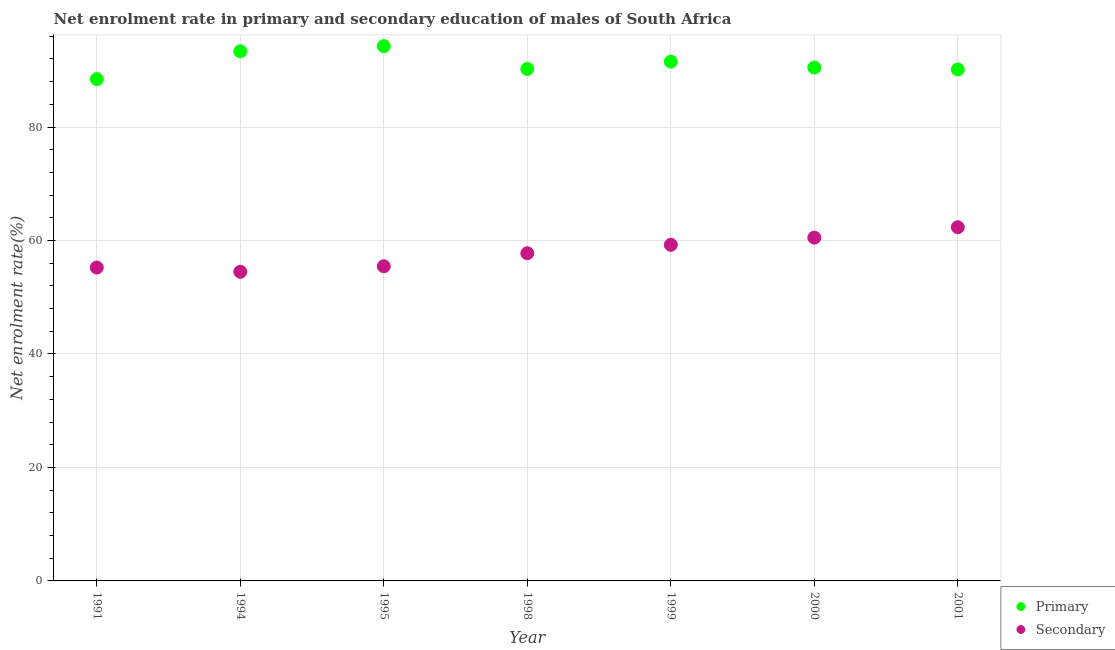How many different coloured dotlines are there?
Your answer should be very brief. 2. Is the number of dotlines equal to the number of legend labels?
Your answer should be very brief. Yes. What is the enrollment rate in primary education in 1994?
Your response must be concise. 93.36. Across all years, what is the maximum enrollment rate in secondary education?
Offer a terse response. 62.34. Across all years, what is the minimum enrollment rate in primary education?
Your answer should be compact. 88.45. In which year was the enrollment rate in secondary education maximum?
Ensure brevity in your answer.  2001. In which year was the enrollment rate in secondary education minimum?
Your answer should be compact. 1994. What is the total enrollment rate in secondary education in the graph?
Provide a short and direct response. 405.04. What is the difference between the enrollment rate in primary education in 1998 and that in 2001?
Provide a short and direct response. 0.09. What is the difference between the enrollment rate in primary education in 1999 and the enrollment rate in secondary education in 2000?
Provide a succinct answer. 31.02. What is the average enrollment rate in primary education per year?
Ensure brevity in your answer.  91.21. In the year 2000, what is the difference between the enrollment rate in secondary education and enrollment rate in primary education?
Your answer should be compact. -29.98. What is the ratio of the enrollment rate in primary education in 1995 to that in 2000?
Your answer should be very brief. 1.04. Is the enrollment rate in primary education in 1995 less than that in 1998?
Offer a terse response. No. What is the difference between the highest and the second highest enrollment rate in primary education?
Ensure brevity in your answer.  0.9. What is the difference between the highest and the lowest enrollment rate in primary education?
Make the answer very short. 5.81. Is the enrollment rate in secondary education strictly less than the enrollment rate in primary education over the years?
Make the answer very short. Yes. How many dotlines are there?
Offer a terse response. 2. How many years are there in the graph?
Offer a very short reply. 7. What is the difference between two consecutive major ticks on the Y-axis?
Your response must be concise. 20. How many legend labels are there?
Offer a very short reply. 2. What is the title of the graph?
Make the answer very short. Net enrolment rate in primary and secondary education of males of South Africa. Does "Non-residents" appear as one of the legend labels in the graph?
Ensure brevity in your answer.  No. What is the label or title of the X-axis?
Your answer should be compact. Year. What is the label or title of the Y-axis?
Offer a very short reply. Net enrolment rate(%). What is the Net enrolment rate(%) of Primary in 1991?
Make the answer very short. 88.45. What is the Net enrolment rate(%) of Secondary in 1991?
Make the answer very short. 55.24. What is the Net enrolment rate(%) in Primary in 1994?
Ensure brevity in your answer.  93.36. What is the Net enrolment rate(%) of Secondary in 1994?
Keep it short and to the point. 54.49. What is the Net enrolment rate(%) in Primary in 1995?
Your answer should be compact. 94.26. What is the Net enrolment rate(%) in Secondary in 1995?
Provide a short and direct response. 55.46. What is the Net enrolment rate(%) in Primary in 1998?
Give a very brief answer. 90.24. What is the Net enrolment rate(%) in Secondary in 1998?
Offer a terse response. 57.76. What is the Net enrolment rate(%) in Primary in 1999?
Offer a terse response. 91.53. What is the Net enrolment rate(%) in Secondary in 1999?
Provide a succinct answer. 59.24. What is the Net enrolment rate(%) of Primary in 2000?
Make the answer very short. 90.49. What is the Net enrolment rate(%) in Secondary in 2000?
Keep it short and to the point. 60.51. What is the Net enrolment rate(%) in Primary in 2001?
Provide a short and direct response. 90.15. What is the Net enrolment rate(%) in Secondary in 2001?
Offer a terse response. 62.34. Across all years, what is the maximum Net enrolment rate(%) in Primary?
Provide a succinct answer. 94.26. Across all years, what is the maximum Net enrolment rate(%) of Secondary?
Provide a succinct answer. 62.34. Across all years, what is the minimum Net enrolment rate(%) in Primary?
Your answer should be compact. 88.45. Across all years, what is the minimum Net enrolment rate(%) of Secondary?
Provide a succinct answer. 54.49. What is the total Net enrolment rate(%) in Primary in the graph?
Your answer should be compact. 638.47. What is the total Net enrolment rate(%) in Secondary in the graph?
Your answer should be very brief. 405.04. What is the difference between the Net enrolment rate(%) of Primary in 1991 and that in 1994?
Offer a very short reply. -4.91. What is the difference between the Net enrolment rate(%) in Secondary in 1991 and that in 1994?
Offer a very short reply. 0.75. What is the difference between the Net enrolment rate(%) of Primary in 1991 and that in 1995?
Your answer should be very brief. -5.81. What is the difference between the Net enrolment rate(%) of Secondary in 1991 and that in 1995?
Offer a terse response. -0.22. What is the difference between the Net enrolment rate(%) in Primary in 1991 and that in 1998?
Your response must be concise. -1.79. What is the difference between the Net enrolment rate(%) in Secondary in 1991 and that in 1998?
Your answer should be compact. -2.51. What is the difference between the Net enrolment rate(%) in Primary in 1991 and that in 1999?
Keep it short and to the point. -3.08. What is the difference between the Net enrolment rate(%) of Secondary in 1991 and that in 1999?
Keep it short and to the point. -4. What is the difference between the Net enrolment rate(%) of Primary in 1991 and that in 2000?
Ensure brevity in your answer.  -2.04. What is the difference between the Net enrolment rate(%) of Secondary in 1991 and that in 2000?
Give a very brief answer. -5.27. What is the difference between the Net enrolment rate(%) in Primary in 1991 and that in 2001?
Make the answer very short. -1.7. What is the difference between the Net enrolment rate(%) in Secondary in 1991 and that in 2001?
Provide a short and direct response. -7.1. What is the difference between the Net enrolment rate(%) in Primary in 1994 and that in 1995?
Your answer should be very brief. -0.9. What is the difference between the Net enrolment rate(%) of Secondary in 1994 and that in 1995?
Make the answer very short. -0.97. What is the difference between the Net enrolment rate(%) of Primary in 1994 and that in 1998?
Give a very brief answer. 3.12. What is the difference between the Net enrolment rate(%) in Secondary in 1994 and that in 1998?
Offer a terse response. -3.27. What is the difference between the Net enrolment rate(%) of Primary in 1994 and that in 1999?
Make the answer very short. 1.83. What is the difference between the Net enrolment rate(%) in Secondary in 1994 and that in 1999?
Make the answer very short. -4.76. What is the difference between the Net enrolment rate(%) in Primary in 1994 and that in 2000?
Provide a short and direct response. 2.87. What is the difference between the Net enrolment rate(%) in Secondary in 1994 and that in 2000?
Your answer should be very brief. -6.02. What is the difference between the Net enrolment rate(%) in Primary in 1994 and that in 2001?
Provide a succinct answer. 3.21. What is the difference between the Net enrolment rate(%) in Secondary in 1994 and that in 2001?
Make the answer very short. -7.85. What is the difference between the Net enrolment rate(%) in Primary in 1995 and that in 1998?
Offer a terse response. 4.02. What is the difference between the Net enrolment rate(%) in Secondary in 1995 and that in 1998?
Your answer should be very brief. -2.29. What is the difference between the Net enrolment rate(%) of Primary in 1995 and that in 1999?
Give a very brief answer. 2.73. What is the difference between the Net enrolment rate(%) of Secondary in 1995 and that in 1999?
Give a very brief answer. -3.78. What is the difference between the Net enrolment rate(%) of Primary in 1995 and that in 2000?
Give a very brief answer. 3.77. What is the difference between the Net enrolment rate(%) in Secondary in 1995 and that in 2000?
Your answer should be compact. -5.05. What is the difference between the Net enrolment rate(%) of Primary in 1995 and that in 2001?
Ensure brevity in your answer.  4.11. What is the difference between the Net enrolment rate(%) of Secondary in 1995 and that in 2001?
Offer a terse response. -6.88. What is the difference between the Net enrolment rate(%) of Primary in 1998 and that in 1999?
Give a very brief answer. -1.29. What is the difference between the Net enrolment rate(%) of Secondary in 1998 and that in 1999?
Provide a short and direct response. -1.49. What is the difference between the Net enrolment rate(%) in Primary in 1998 and that in 2000?
Give a very brief answer. -0.25. What is the difference between the Net enrolment rate(%) of Secondary in 1998 and that in 2000?
Offer a very short reply. -2.75. What is the difference between the Net enrolment rate(%) in Primary in 1998 and that in 2001?
Offer a terse response. 0.09. What is the difference between the Net enrolment rate(%) in Secondary in 1998 and that in 2001?
Offer a terse response. -4.58. What is the difference between the Net enrolment rate(%) of Primary in 1999 and that in 2000?
Provide a short and direct response. 1.04. What is the difference between the Net enrolment rate(%) in Secondary in 1999 and that in 2000?
Provide a short and direct response. -1.26. What is the difference between the Net enrolment rate(%) in Primary in 1999 and that in 2001?
Ensure brevity in your answer.  1.38. What is the difference between the Net enrolment rate(%) in Secondary in 1999 and that in 2001?
Your answer should be compact. -3.1. What is the difference between the Net enrolment rate(%) of Primary in 2000 and that in 2001?
Offer a very short reply. 0.34. What is the difference between the Net enrolment rate(%) of Secondary in 2000 and that in 2001?
Provide a short and direct response. -1.83. What is the difference between the Net enrolment rate(%) in Primary in 1991 and the Net enrolment rate(%) in Secondary in 1994?
Offer a terse response. 33.96. What is the difference between the Net enrolment rate(%) of Primary in 1991 and the Net enrolment rate(%) of Secondary in 1995?
Make the answer very short. 32.99. What is the difference between the Net enrolment rate(%) in Primary in 1991 and the Net enrolment rate(%) in Secondary in 1998?
Provide a short and direct response. 30.69. What is the difference between the Net enrolment rate(%) of Primary in 1991 and the Net enrolment rate(%) of Secondary in 1999?
Offer a very short reply. 29.2. What is the difference between the Net enrolment rate(%) of Primary in 1991 and the Net enrolment rate(%) of Secondary in 2000?
Your response must be concise. 27.94. What is the difference between the Net enrolment rate(%) in Primary in 1991 and the Net enrolment rate(%) in Secondary in 2001?
Offer a very short reply. 26.11. What is the difference between the Net enrolment rate(%) in Primary in 1994 and the Net enrolment rate(%) in Secondary in 1995?
Provide a short and direct response. 37.9. What is the difference between the Net enrolment rate(%) of Primary in 1994 and the Net enrolment rate(%) of Secondary in 1998?
Provide a short and direct response. 35.6. What is the difference between the Net enrolment rate(%) of Primary in 1994 and the Net enrolment rate(%) of Secondary in 1999?
Keep it short and to the point. 34.12. What is the difference between the Net enrolment rate(%) in Primary in 1994 and the Net enrolment rate(%) in Secondary in 2000?
Offer a terse response. 32.85. What is the difference between the Net enrolment rate(%) of Primary in 1994 and the Net enrolment rate(%) of Secondary in 2001?
Provide a succinct answer. 31.02. What is the difference between the Net enrolment rate(%) in Primary in 1995 and the Net enrolment rate(%) in Secondary in 1998?
Keep it short and to the point. 36.5. What is the difference between the Net enrolment rate(%) in Primary in 1995 and the Net enrolment rate(%) in Secondary in 1999?
Make the answer very short. 35.02. What is the difference between the Net enrolment rate(%) in Primary in 1995 and the Net enrolment rate(%) in Secondary in 2000?
Your response must be concise. 33.75. What is the difference between the Net enrolment rate(%) of Primary in 1995 and the Net enrolment rate(%) of Secondary in 2001?
Make the answer very short. 31.92. What is the difference between the Net enrolment rate(%) of Primary in 1998 and the Net enrolment rate(%) of Secondary in 1999?
Your answer should be very brief. 30.99. What is the difference between the Net enrolment rate(%) of Primary in 1998 and the Net enrolment rate(%) of Secondary in 2000?
Your answer should be very brief. 29.73. What is the difference between the Net enrolment rate(%) in Primary in 1998 and the Net enrolment rate(%) in Secondary in 2001?
Provide a short and direct response. 27.9. What is the difference between the Net enrolment rate(%) of Primary in 1999 and the Net enrolment rate(%) of Secondary in 2000?
Offer a terse response. 31.02. What is the difference between the Net enrolment rate(%) in Primary in 1999 and the Net enrolment rate(%) in Secondary in 2001?
Ensure brevity in your answer.  29.19. What is the difference between the Net enrolment rate(%) of Primary in 2000 and the Net enrolment rate(%) of Secondary in 2001?
Offer a terse response. 28.15. What is the average Net enrolment rate(%) in Primary per year?
Your answer should be compact. 91.21. What is the average Net enrolment rate(%) in Secondary per year?
Your answer should be compact. 57.86. In the year 1991, what is the difference between the Net enrolment rate(%) in Primary and Net enrolment rate(%) in Secondary?
Offer a terse response. 33.21. In the year 1994, what is the difference between the Net enrolment rate(%) of Primary and Net enrolment rate(%) of Secondary?
Give a very brief answer. 38.87. In the year 1995, what is the difference between the Net enrolment rate(%) in Primary and Net enrolment rate(%) in Secondary?
Provide a succinct answer. 38.8. In the year 1998, what is the difference between the Net enrolment rate(%) of Primary and Net enrolment rate(%) of Secondary?
Make the answer very short. 32.48. In the year 1999, what is the difference between the Net enrolment rate(%) of Primary and Net enrolment rate(%) of Secondary?
Your response must be concise. 32.28. In the year 2000, what is the difference between the Net enrolment rate(%) in Primary and Net enrolment rate(%) in Secondary?
Offer a terse response. 29.98. In the year 2001, what is the difference between the Net enrolment rate(%) in Primary and Net enrolment rate(%) in Secondary?
Ensure brevity in your answer.  27.81. What is the ratio of the Net enrolment rate(%) in Secondary in 1991 to that in 1994?
Make the answer very short. 1.01. What is the ratio of the Net enrolment rate(%) of Primary in 1991 to that in 1995?
Provide a succinct answer. 0.94. What is the ratio of the Net enrolment rate(%) in Primary in 1991 to that in 1998?
Give a very brief answer. 0.98. What is the ratio of the Net enrolment rate(%) of Secondary in 1991 to that in 1998?
Offer a terse response. 0.96. What is the ratio of the Net enrolment rate(%) in Primary in 1991 to that in 1999?
Give a very brief answer. 0.97. What is the ratio of the Net enrolment rate(%) in Secondary in 1991 to that in 1999?
Offer a terse response. 0.93. What is the ratio of the Net enrolment rate(%) in Primary in 1991 to that in 2000?
Your response must be concise. 0.98. What is the ratio of the Net enrolment rate(%) in Secondary in 1991 to that in 2000?
Your response must be concise. 0.91. What is the ratio of the Net enrolment rate(%) in Primary in 1991 to that in 2001?
Offer a terse response. 0.98. What is the ratio of the Net enrolment rate(%) of Secondary in 1991 to that in 2001?
Make the answer very short. 0.89. What is the ratio of the Net enrolment rate(%) in Secondary in 1994 to that in 1995?
Ensure brevity in your answer.  0.98. What is the ratio of the Net enrolment rate(%) in Primary in 1994 to that in 1998?
Your response must be concise. 1.03. What is the ratio of the Net enrolment rate(%) of Secondary in 1994 to that in 1998?
Your answer should be very brief. 0.94. What is the ratio of the Net enrolment rate(%) of Secondary in 1994 to that in 1999?
Ensure brevity in your answer.  0.92. What is the ratio of the Net enrolment rate(%) of Primary in 1994 to that in 2000?
Your response must be concise. 1.03. What is the ratio of the Net enrolment rate(%) in Secondary in 1994 to that in 2000?
Ensure brevity in your answer.  0.9. What is the ratio of the Net enrolment rate(%) in Primary in 1994 to that in 2001?
Keep it short and to the point. 1.04. What is the ratio of the Net enrolment rate(%) of Secondary in 1994 to that in 2001?
Your answer should be very brief. 0.87. What is the ratio of the Net enrolment rate(%) of Primary in 1995 to that in 1998?
Your answer should be very brief. 1.04. What is the ratio of the Net enrolment rate(%) of Secondary in 1995 to that in 1998?
Your response must be concise. 0.96. What is the ratio of the Net enrolment rate(%) in Primary in 1995 to that in 1999?
Offer a terse response. 1.03. What is the ratio of the Net enrolment rate(%) in Secondary in 1995 to that in 1999?
Provide a succinct answer. 0.94. What is the ratio of the Net enrolment rate(%) of Primary in 1995 to that in 2000?
Your answer should be very brief. 1.04. What is the ratio of the Net enrolment rate(%) of Secondary in 1995 to that in 2000?
Keep it short and to the point. 0.92. What is the ratio of the Net enrolment rate(%) in Primary in 1995 to that in 2001?
Offer a very short reply. 1.05. What is the ratio of the Net enrolment rate(%) of Secondary in 1995 to that in 2001?
Provide a short and direct response. 0.89. What is the ratio of the Net enrolment rate(%) of Primary in 1998 to that in 1999?
Offer a terse response. 0.99. What is the ratio of the Net enrolment rate(%) of Secondary in 1998 to that in 1999?
Provide a succinct answer. 0.97. What is the ratio of the Net enrolment rate(%) of Secondary in 1998 to that in 2000?
Offer a terse response. 0.95. What is the ratio of the Net enrolment rate(%) in Primary in 1998 to that in 2001?
Your response must be concise. 1. What is the ratio of the Net enrolment rate(%) of Secondary in 1998 to that in 2001?
Offer a terse response. 0.93. What is the ratio of the Net enrolment rate(%) in Primary in 1999 to that in 2000?
Your answer should be compact. 1.01. What is the ratio of the Net enrolment rate(%) of Secondary in 1999 to that in 2000?
Ensure brevity in your answer.  0.98. What is the ratio of the Net enrolment rate(%) of Primary in 1999 to that in 2001?
Provide a succinct answer. 1.02. What is the ratio of the Net enrolment rate(%) of Secondary in 1999 to that in 2001?
Your answer should be very brief. 0.95. What is the ratio of the Net enrolment rate(%) of Primary in 2000 to that in 2001?
Keep it short and to the point. 1. What is the ratio of the Net enrolment rate(%) in Secondary in 2000 to that in 2001?
Ensure brevity in your answer.  0.97. What is the difference between the highest and the second highest Net enrolment rate(%) in Primary?
Ensure brevity in your answer.  0.9. What is the difference between the highest and the second highest Net enrolment rate(%) in Secondary?
Your response must be concise. 1.83. What is the difference between the highest and the lowest Net enrolment rate(%) of Primary?
Provide a short and direct response. 5.81. What is the difference between the highest and the lowest Net enrolment rate(%) of Secondary?
Give a very brief answer. 7.85. 